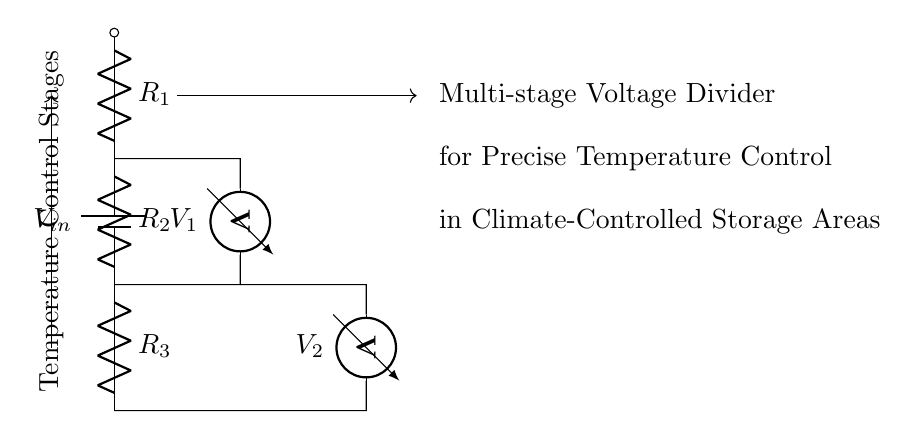What is the input voltage of this circuit? The input voltage, denoted as V_in, corresponds to the voltage at the top of the circuit, which is the supply voltage connected to the battery.
Answer: V_in What are the values of the resistors in this circuit? The circuit shows three resistors labeled R_1, R_2, and R_3. Their specific values are not provided in the diagram, thus remain undefined.
Answer: R_1, R_2, R_3 How many voltage measurements can be taken from this circuit? The circuit can measure two voltages: V_1 across R_1 and R_2, and V_2 across R_2 and R_3.
Answer: 2 What role does the multi-stage design play in this circuit? The multi-stage design allows for finer control over the output voltages (V_1, V_2), making it more suitable for precise temperature control applications by dividing the input voltage into smaller, manageable levels.
Answer: Precise control What happens if R_2 is increased? Increasing R_2 will result in a higher voltage across R_1 (V_1) while lowering the voltage across R_2 (V_2) since larger resistance has a more significant effect on voltage division.
Answer: V_1 increases, V_2 decreases What is the function of the voltmeter in this circuit? The voltmeters measure the voltages V_1 and V_2 across the respective resistor combinations, enabling the monitoring of voltage distribution and temperature effects accurately.
Answer: Measure voltage 